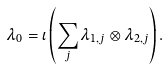<formula> <loc_0><loc_0><loc_500><loc_500>\lambda _ { 0 } = \iota \left ( \sum _ { j } \lambda _ { 1 , j } \otimes \lambda _ { 2 , j } \right ) .</formula> 